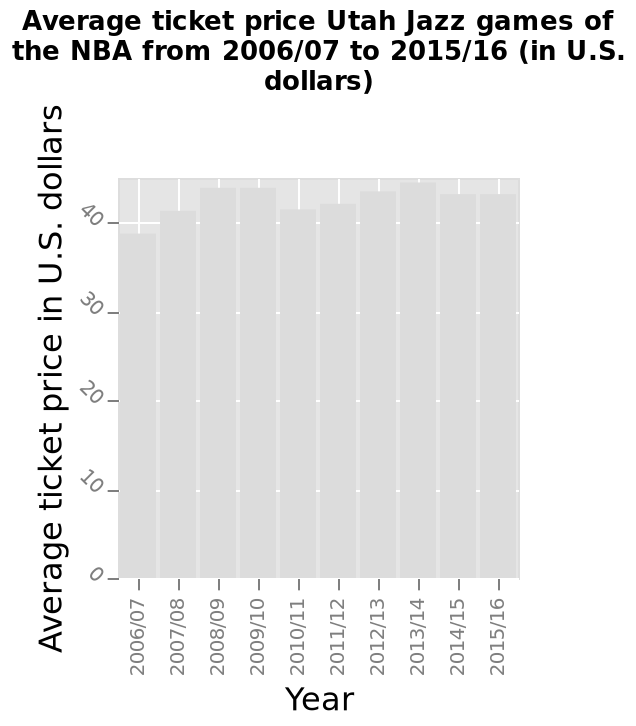<image>
What does the y-axis show?  The y-axis shows the average ticket price in U.S. dollars. Is there a clear trend in the fluctuation of ticket prices? No, the prices seem to fluctuate without a clear trend. What type of scale is used for the x-axis?  The x-axis uses a categorical scale. 